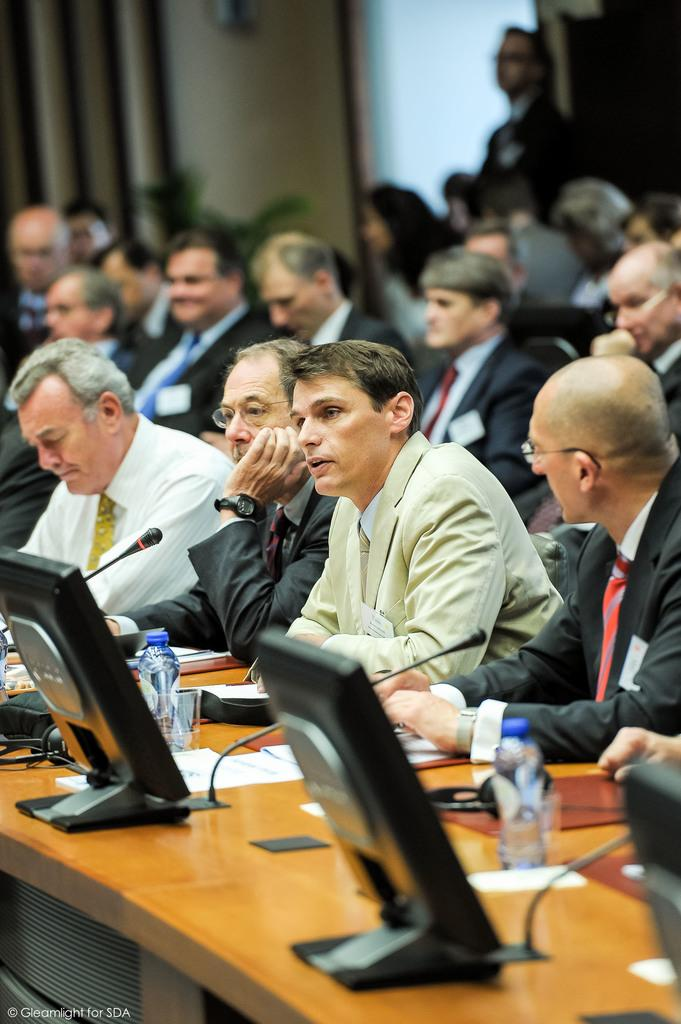What are the people in the image doing? There is a group of people sitting on chairs in the image. What objects are in front of the people? There are systems in front of the people. What can be seen near the people for hydration? Water bottles are visible in the image. What might the people be using to communicate? Microphones are present in the image. What type of material might the people be using for reference or note-taking? There are papers in the image. What is the color and type of furniture in the image? There is a brown color table in the image. How many beggars can be seen in the image? There are no beggars present in the image. What type of toothpaste is visible on the table in the image? There is no toothpaste visible in the image. 